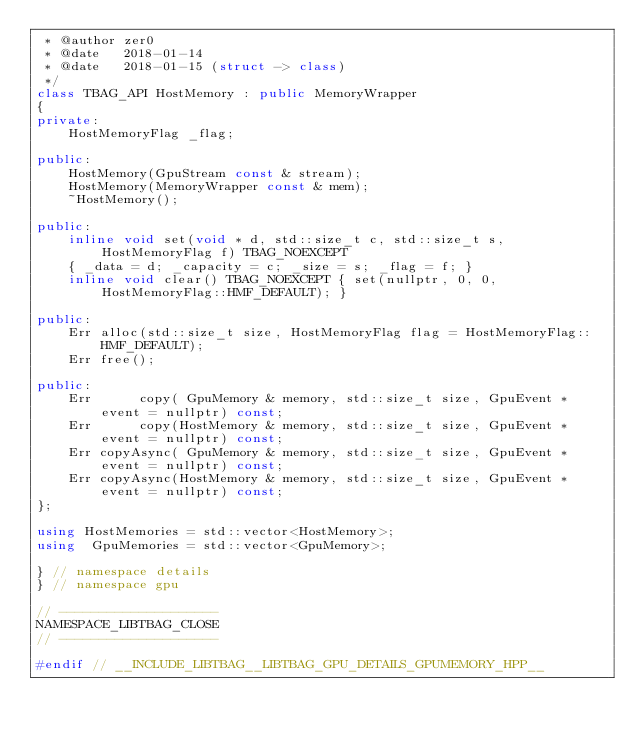<code> <loc_0><loc_0><loc_500><loc_500><_C++_> * @author zer0
 * @date   2018-01-14
 * @date   2018-01-15 (struct -> class)
 */
class TBAG_API HostMemory : public MemoryWrapper
{
private:
    HostMemoryFlag _flag;

public:
    HostMemory(GpuStream const & stream);
    HostMemory(MemoryWrapper const & mem);
    ~HostMemory();

public:
    inline void set(void * d, std::size_t c, std::size_t s, HostMemoryFlag f) TBAG_NOEXCEPT
    { _data = d; _capacity = c; _size = s; _flag = f; }
    inline void clear() TBAG_NOEXCEPT { set(nullptr, 0, 0, HostMemoryFlag::HMF_DEFAULT); }

public:
    Err alloc(std::size_t size, HostMemoryFlag flag = HostMemoryFlag::HMF_DEFAULT);
    Err free();

public:
    Err      copy( GpuMemory & memory, std::size_t size, GpuEvent * event = nullptr) const;
    Err      copy(HostMemory & memory, std::size_t size, GpuEvent * event = nullptr) const;
    Err copyAsync( GpuMemory & memory, std::size_t size, GpuEvent * event = nullptr) const;
    Err copyAsync(HostMemory & memory, std::size_t size, GpuEvent * event = nullptr) const;
};

using HostMemories = std::vector<HostMemory>;
using  GpuMemories = std::vector<GpuMemory>;

} // namespace details
} // namespace gpu

// --------------------
NAMESPACE_LIBTBAG_CLOSE
// --------------------

#endif // __INCLUDE_LIBTBAG__LIBTBAG_GPU_DETAILS_GPUMEMORY_HPP__

</code> 